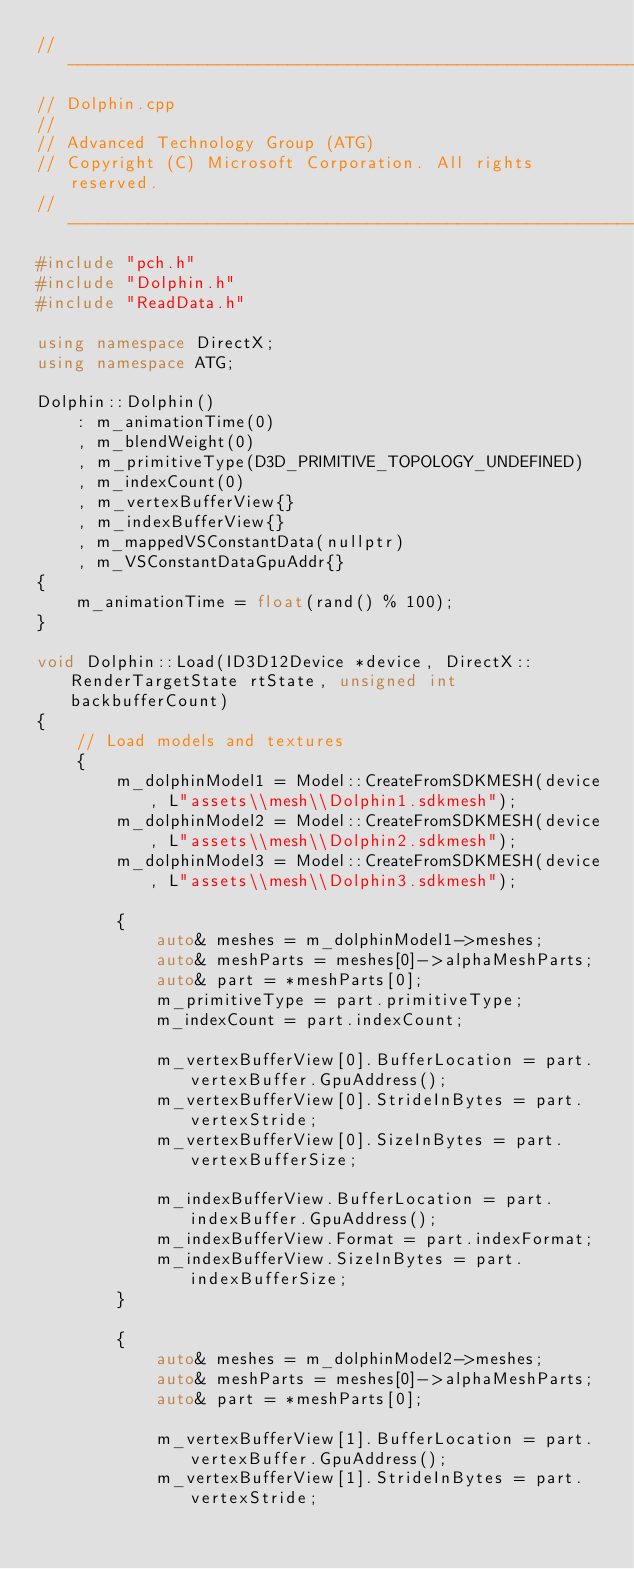Convert code to text. <code><loc_0><loc_0><loc_500><loc_500><_C++_>//--------------------------------------------------------------------------------------
// Dolphin.cpp
//
// Advanced Technology Group (ATG)
// Copyright (C) Microsoft Corporation. All rights reserved.
//--------------------------------------------------------------------------------------
#include "pch.h"
#include "Dolphin.h"
#include "ReadData.h"

using namespace DirectX;
using namespace ATG;

Dolphin::Dolphin()
    : m_animationTime(0)
    , m_blendWeight(0)
    , m_primitiveType(D3D_PRIMITIVE_TOPOLOGY_UNDEFINED)
    , m_indexCount(0)
    , m_vertexBufferView{}
    , m_indexBufferView{}
    , m_mappedVSConstantData(nullptr)
    , m_VSConstantDataGpuAddr{}
{
    m_animationTime = float(rand() % 100);
}

void Dolphin::Load(ID3D12Device *device, DirectX::RenderTargetState rtState, unsigned int backbufferCount)
{
    // Load models and textures
    {
        m_dolphinModel1 = Model::CreateFromSDKMESH(device, L"assets\\mesh\\Dolphin1.sdkmesh");
        m_dolphinModel2 = Model::CreateFromSDKMESH(device, L"assets\\mesh\\Dolphin2.sdkmesh");
        m_dolphinModel3 = Model::CreateFromSDKMESH(device, L"assets\\mesh\\Dolphin3.sdkmesh");

        {
            auto& meshes = m_dolphinModel1->meshes;
            auto& meshParts = meshes[0]->alphaMeshParts;
            auto& part = *meshParts[0];
            m_primitiveType = part.primitiveType;
            m_indexCount = part.indexCount;

            m_vertexBufferView[0].BufferLocation = part.vertexBuffer.GpuAddress();
            m_vertexBufferView[0].StrideInBytes = part.vertexStride;
            m_vertexBufferView[0].SizeInBytes = part.vertexBufferSize;

            m_indexBufferView.BufferLocation = part.indexBuffer.GpuAddress();
            m_indexBufferView.Format = part.indexFormat;
            m_indexBufferView.SizeInBytes = part.indexBufferSize;
        }

        {
            auto& meshes = m_dolphinModel2->meshes;
            auto& meshParts = meshes[0]->alphaMeshParts;
            auto& part = *meshParts[0];

            m_vertexBufferView[1].BufferLocation = part.vertexBuffer.GpuAddress();
            m_vertexBufferView[1].StrideInBytes = part.vertexStride;</code> 